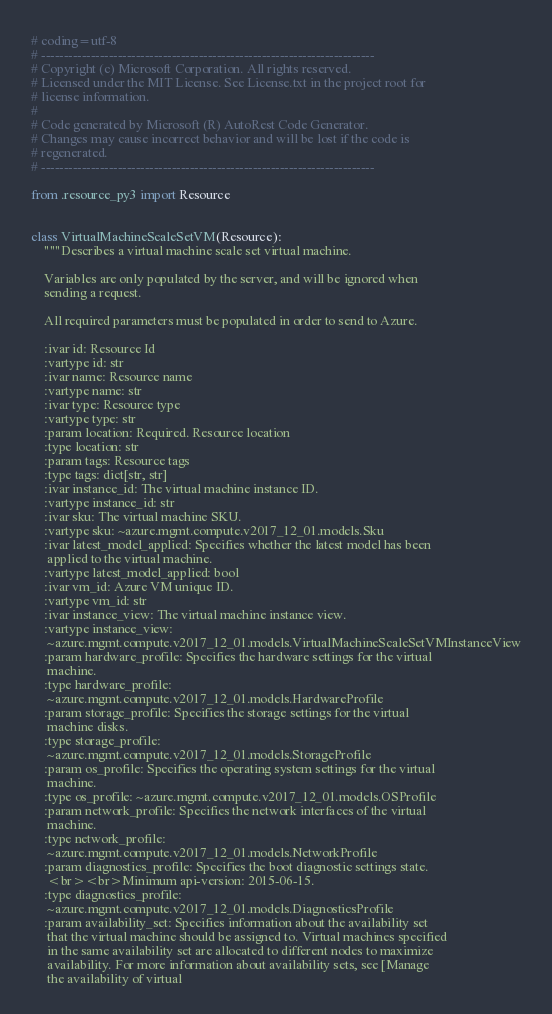Convert code to text. <code><loc_0><loc_0><loc_500><loc_500><_Python_># coding=utf-8
# --------------------------------------------------------------------------
# Copyright (c) Microsoft Corporation. All rights reserved.
# Licensed under the MIT License. See License.txt in the project root for
# license information.
#
# Code generated by Microsoft (R) AutoRest Code Generator.
# Changes may cause incorrect behavior and will be lost if the code is
# regenerated.
# --------------------------------------------------------------------------

from .resource_py3 import Resource


class VirtualMachineScaleSetVM(Resource):
    """Describes a virtual machine scale set virtual machine.

    Variables are only populated by the server, and will be ignored when
    sending a request.

    All required parameters must be populated in order to send to Azure.

    :ivar id: Resource Id
    :vartype id: str
    :ivar name: Resource name
    :vartype name: str
    :ivar type: Resource type
    :vartype type: str
    :param location: Required. Resource location
    :type location: str
    :param tags: Resource tags
    :type tags: dict[str, str]
    :ivar instance_id: The virtual machine instance ID.
    :vartype instance_id: str
    :ivar sku: The virtual machine SKU.
    :vartype sku: ~azure.mgmt.compute.v2017_12_01.models.Sku
    :ivar latest_model_applied: Specifies whether the latest model has been
     applied to the virtual machine.
    :vartype latest_model_applied: bool
    :ivar vm_id: Azure VM unique ID.
    :vartype vm_id: str
    :ivar instance_view: The virtual machine instance view.
    :vartype instance_view:
     ~azure.mgmt.compute.v2017_12_01.models.VirtualMachineScaleSetVMInstanceView
    :param hardware_profile: Specifies the hardware settings for the virtual
     machine.
    :type hardware_profile:
     ~azure.mgmt.compute.v2017_12_01.models.HardwareProfile
    :param storage_profile: Specifies the storage settings for the virtual
     machine disks.
    :type storage_profile:
     ~azure.mgmt.compute.v2017_12_01.models.StorageProfile
    :param os_profile: Specifies the operating system settings for the virtual
     machine.
    :type os_profile: ~azure.mgmt.compute.v2017_12_01.models.OSProfile
    :param network_profile: Specifies the network interfaces of the virtual
     machine.
    :type network_profile:
     ~azure.mgmt.compute.v2017_12_01.models.NetworkProfile
    :param diagnostics_profile: Specifies the boot diagnostic settings state.
     <br><br>Minimum api-version: 2015-06-15.
    :type diagnostics_profile:
     ~azure.mgmt.compute.v2017_12_01.models.DiagnosticsProfile
    :param availability_set: Specifies information about the availability set
     that the virtual machine should be assigned to. Virtual machines specified
     in the same availability set are allocated to different nodes to maximize
     availability. For more information about availability sets, see [Manage
     the availability of virtual</code> 